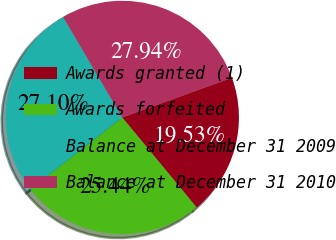Convert chart to OTSL. <chart><loc_0><loc_0><loc_500><loc_500><pie_chart><fcel>Awards granted (1)<fcel>Awards forfeited<fcel>Balance at December 31 2009<fcel>Balance at December 31 2010<nl><fcel>19.53%<fcel>25.44%<fcel>27.1%<fcel>27.94%<nl></chart> 